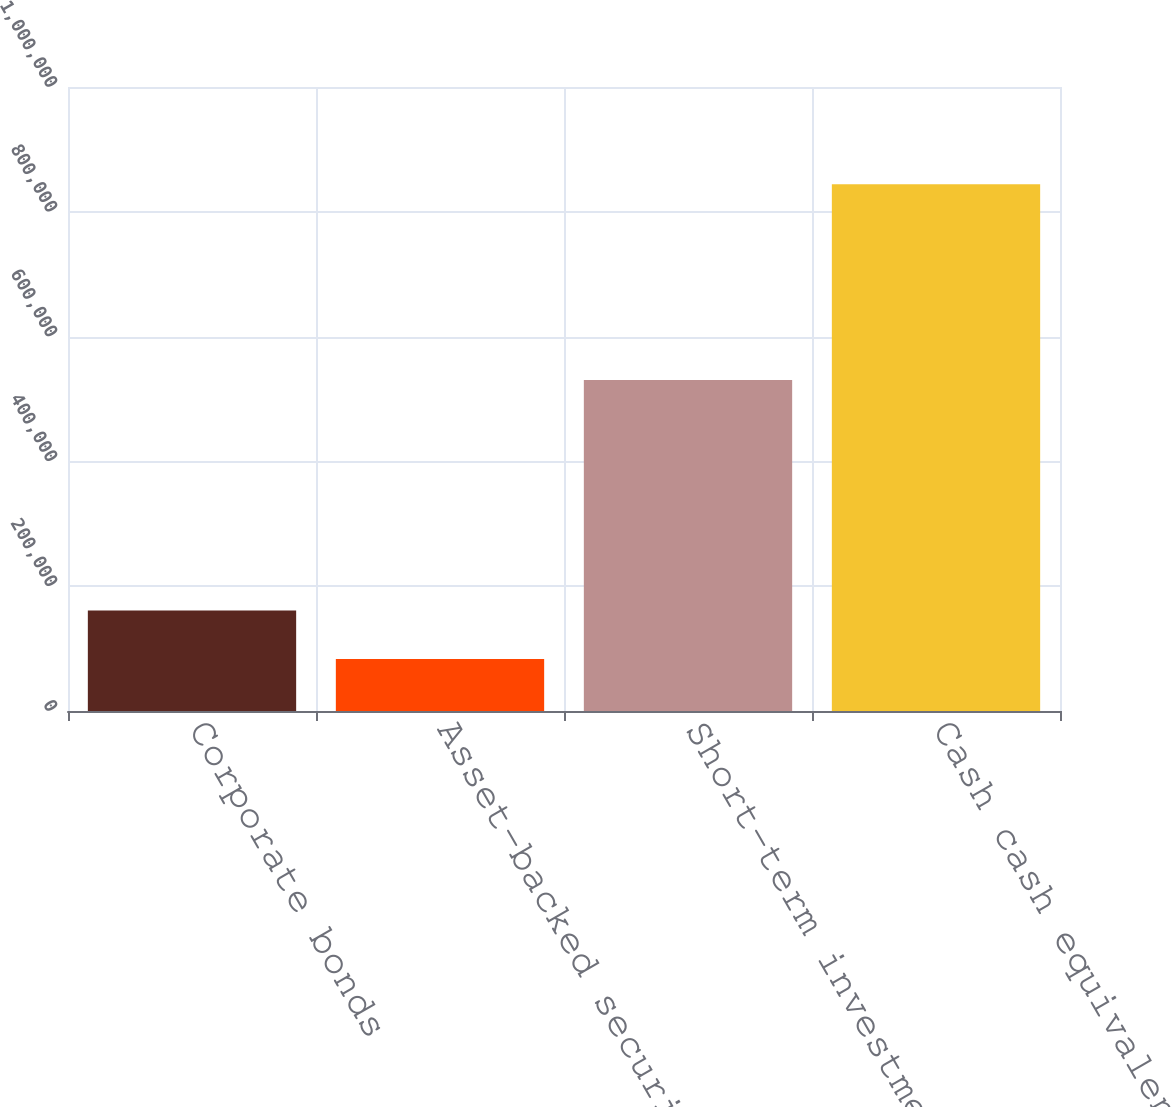Convert chart to OTSL. <chart><loc_0><loc_0><loc_500><loc_500><bar_chart><fcel>Corporate bonds<fcel>Asset-backed securities<fcel>Short-term investments<fcel>Cash cash equivalents and<nl><fcel>160907<fcel>83517<fcel>530467<fcel>844084<nl></chart> 